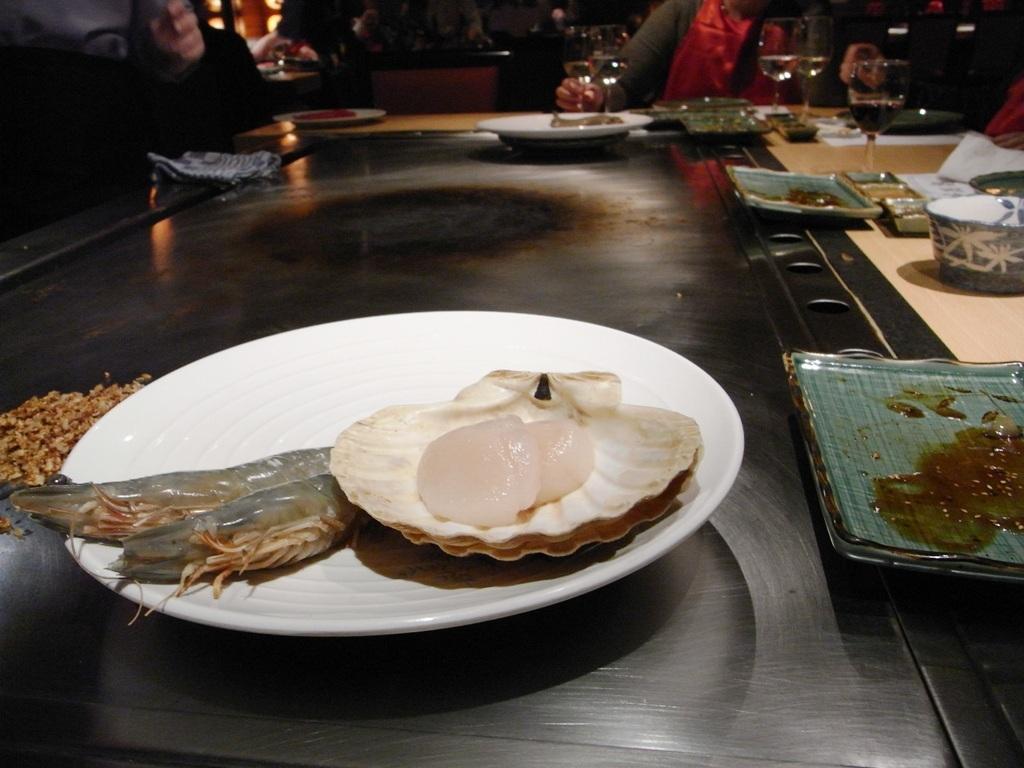Can you describe this image briefly? In this image there is a table. On top of the table there are glasses. There are food items in a plate and there are a few other objects. In front of the table there are people. Behind them there are a few objects. 